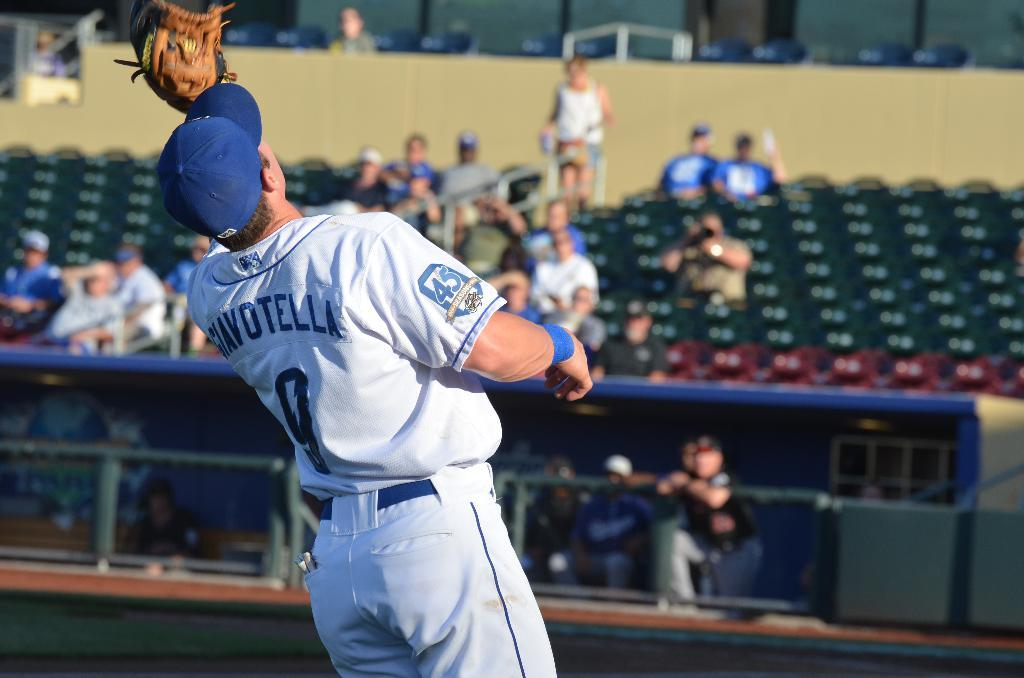<image>
Share a concise interpretation of the image provided. Player number 9 reached up with his glove to catch the ball. 